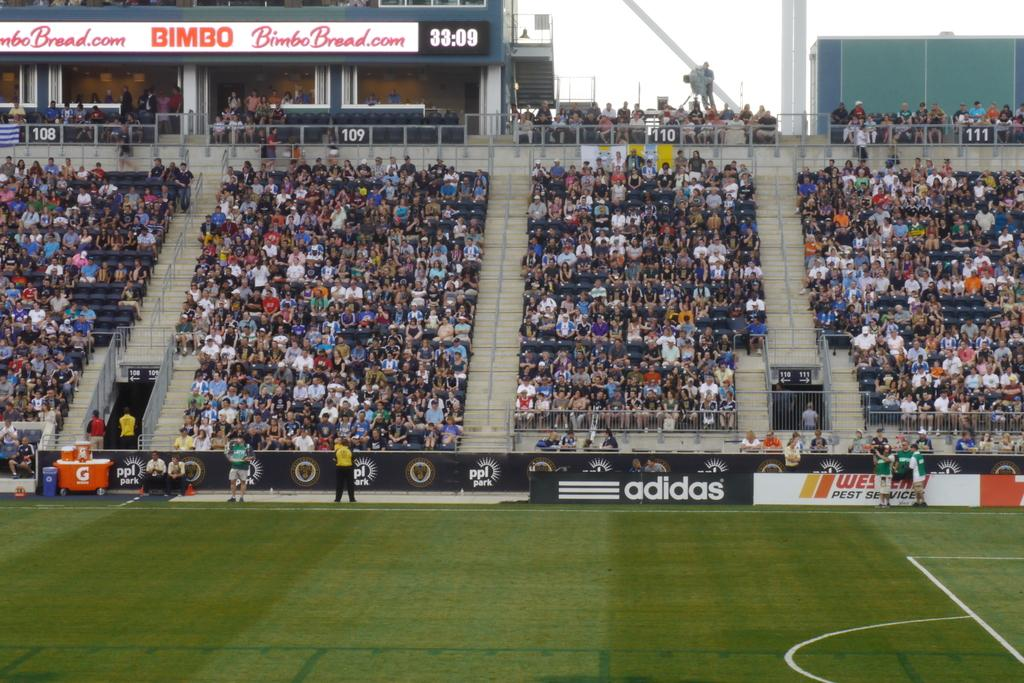<image>
Relay a brief, clear account of the picture shown. An adidas logo can be seen in a stadium. 